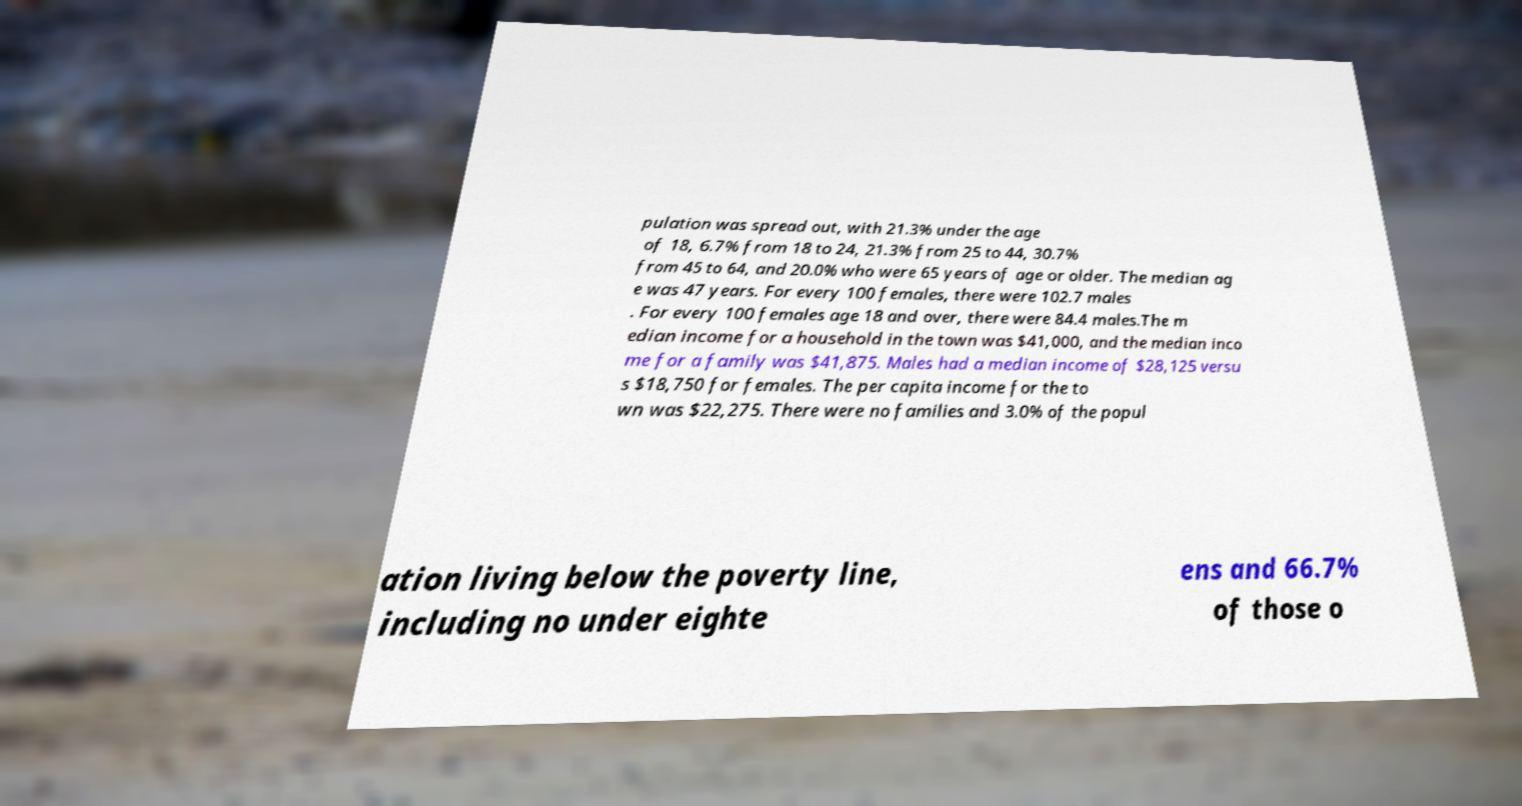Can you accurately transcribe the text from the provided image for me? pulation was spread out, with 21.3% under the age of 18, 6.7% from 18 to 24, 21.3% from 25 to 44, 30.7% from 45 to 64, and 20.0% who were 65 years of age or older. The median ag e was 47 years. For every 100 females, there were 102.7 males . For every 100 females age 18 and over, there were 84.4 males.The m edian income for a household in the town was $41,000, and the median inco me for a family was $41,875. Males had a median income of $28,125 versu s $18,750 for females. The per capita income for the to wn was $22,275. There were no families and 3.0% of the popul ation living below the poverty line, including no under eighte ens and 66.7% of those o 